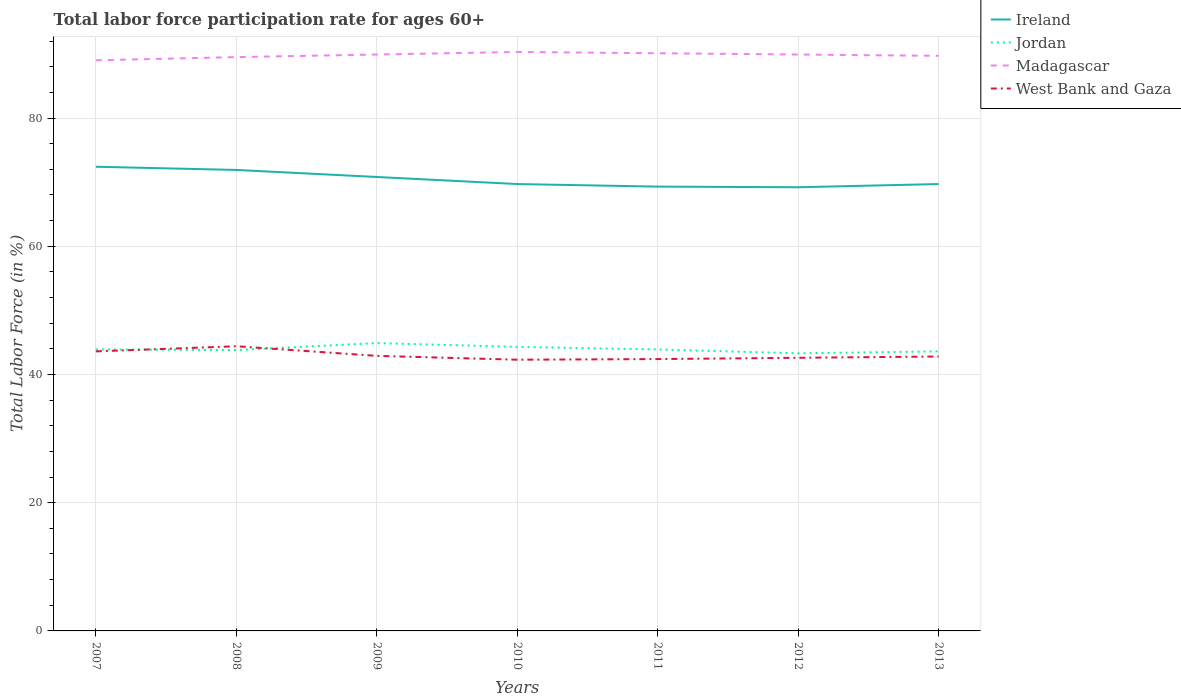How many different coloured lines are there?
Keep it short and to the point. 4. Is the number of lines equal to the number of legend labels?
Give a very brief answer. Yes. Across all years, what is the maximum labor force participation rate in Ireland?
Make the answer very short. 69.2. In which year was the labor force participation rate in Ireland maximum?
Ensure brevity in your answer.  2012. What is the total labor force participation rate in Jordan in the graph?
Offer a very short reply. 0.6. What is the difference between the highest and the second highest labor force participation rate in Ireland?
Your answer should be compact. 3.2. What is the difference between the highest and the lowest labor force participation rate in West Bank and Gaza?
Give a very brief answer. 2. Is the labor force participation rate in Jordan strictly greater than the labor force participation rate in Ireland over the years?
Keep it short and to the point. Yes. How many years are there in the graph?
Offer a very short reply. 7. What is the difference between two consecutive major ticks on the Y-axis?
Make the answer very short. 20. Does the graph contain any zero values?
Provide a short and direct response. No. Does the graph contain grids?
Keep it short and to the point. Yes. How many legend labels are there?
Your response must be concise. 4. How are the legend labels stacked?
Provide a short and direct response. Vertical. What is the title of the graph?
Offer a very short reply. Total labor force participation rate for ages 60+. What is the Total Labor Force (in %) of Ireland in 2007?
Make the answer very short. 72.4. What is the Total Labor Force (in %) of Jordan in 2007?
Your answer should be compact. 43.9. What is the Total Labor Force (in %) of Madagascar in 2007?
Offer a terse response. 89. What is the Total Labor Force (in %) of West Bank and Gaza in 2007?
Give a very brief answer. 43.6. What is the Total Labor Force (in %) of Ireland in 2008?
Provide a short and direct response. 71.9. What is the Total Labor Force (in %) of Jordan in 2008?
Provide a succinct answer. 43.8. What is the Total Labor Force (in %) of Madagascar in 2008?
Your answer should be very brief. 89.5. What is the Total Labor Force (in %) in West Bank and Gaza in 2008?
Your response must be concise. 44.4. What is the Total Labor Force (in %) in Ireland in 2009?
Your response must be concise. 70.8. What is the Total Labor Force (in %) in Jordan in 2009?
Your answer should be compact. 44.9. What is the Total Labor Force (in %) in Madagascar in 2009?
Your answer should be very brief. 89.9. What is the Total Labor Force (in %) of West Bank and Gaza in 2009?
Offer a very short reply. 42.9. What is the Total Labor Force (in %) in Ireland in 2010?
Provide a short and direct response. 69.7. What is the Total Labor Force (in %) in Jordan in 2010?
Provide a short and direct response. 44.3. What is the Total Labor Force (in %) of Madagascar in 2010?
Give a very brief answer. 90.3. What is the Total Labor Force (in %) of West Bank and Gaza in 2010?
Give a very brief answer. 42.3. What is the Total Labor Force (in %) of Ireland in 2011?
Provide a succinct answer. 69.3. What is the Total Labor Force (in %) of Jordan in 2011?
Provide a succinct answer. 43.9. What is the Total Labor Force (in %) of Madagascar in 2011?
Keep it short and to the point. 90.1. What is the Total Labor Force (in %) in West Bank and Gaza in 2011?
Ensure brevity in your answer.  42.4. What is the Total Labor Force (in %) of Ireland in 2012?
Your answer should be compact. 69.2. What is the Total Labor Force (in %) in Jordan in 2012?
Provide a short and direct response. 43.3. What is the Total Labor Force (in %) of Madagascar in 2012?
Provide a short and direct response. 89.9. What is the Total Labor Force (in %) of West Bank and Gaza in 2012?
Your answer should be very brief. 42.6. What is the Total Labor Force (in %) of Ireland in 2013?
Your response must be concise. 69.7. What is the Total Labor Force (in %) of Jordan in 2013?
Offer a terse response. 43.6. What is the Total Labor Force (in %) in Madagascar in 2013?
Give a very brief answer. 89.7. What is the Total Labor Force (in %) in West Bank and Gaza in 2013?
Keep it short and to the point. 42.8. Across all years, what is the maximum Total Labor Force (in %) in Ireland?
Provide a short and direct response. 72.4. Across all years, what is the maximum Total Labor Force (in %) of Jordan?
Your answer should be compact. 44.9. Across all years, what is the maximum Total Labor Force (in %) of Madagascar?
Your answer should be compact. 90.3. Across all years, what is the maximum Total Labor Force (in %) in West Bank and Gaza?
Provide a succinct answer. 44.4. Across all years, what is the minimum Total Labor Force (in %) in Ireland?
Provide a succinct answer. 69.2. Across all years, what is the minimum Total Labor Force (in %) of Jordan?
Your answer should be very brief. 43.3. Across all years, what is the minimum Total Labor Force (in %) of Madagascar?
Your answer should be very brief. 89. Across all years, what is the minimum Total Labor Force (in %) in West Bank and Gaza?
Your response must be concise. 42.3. What is the total Total Labor Force (in %) of Ireland in the graph?
Ensure brevity in your answer.  493. What is the total Total Labor Force (in %) of Jordan in the graph?
Offer a terse response. 307.7. What is the total Total Labor Force (in %) in Madagascar in the graph?
Offer a very short reply. 628.4. What is the total Total Labor Force (in %) of West Bank and Gaza in the graph?
Your answer should be very brief. 301. What is the difference between the Total Labor Force (in %) in Jordan in 2007 and that in 2008?
Your response must be concise. 0.1. What is the difference between the Total Labor Force (in %) in Madagascar in 2007 and that in 2008?
Your response must be concise. -0.5. What is the difference between the Total Labor Force (in %) in Ireland in 2007 and that in 2009?
Give a very brief answer. 1.6. What is the difference between the Total Labor Force (in %) in Ireland in 2007 and that in 2010?
Keep it short and to the point. 2.7. What is the difference between the Total Labor Force (in %) in Jordan in 2007 and that in 2010?
Offer a terse response. -0.4. What is the difference between the Total Labor Force (in %) in Madagascar in 2007 and that in 2011?
Keep it short and to the point. -1.1. What is the difference between the Total Labor Force (in %) in Ireland in 2007 and that in 2012?
Offer a very short reply. 3.2. What is the difference between the Total Labor Force (in %) in Jordan in 2007 and that in 2012?
Provide a short and direct response. 0.6. What is the difference between the Total Labor Force (in %) in Madagascar in 2007 and that in 2012?
Offer a very short reply. -0.9. What is the difference between the Total Labor Force (in %) in West Bank and Gaza in 2007 and that in 2012?
Your response must be concise. 1. What is the difference between the Total Labor Force (in %) of Ireland in 2007 and that in 2013?
Your answer should be very brief. 2.7. What is the difference between the Total Labor Force (in %) of Jordan in 2007 and that in 2013?
Give a very brief answer. 0.3. What is the difference between the Total Labor Force (in %) of Madagascar in 2007 and that in 2013?
Your response must be concise. -0.7. What is the difference between the Total Labor Force (in %) of Jordan in 2008 and that in 2009?
Offer a terse response. -1.1. What is the difference between the Total Labor Force (in %) in Jordan in 2008 and that in 2010?
Your answer should be compact. -0.5. What is the difference between the Total Labor Force (in %) in Madagascar in 2008 and that in 2010?
Your answer should be very brief. -0.8. What is the difference between the Total Labor Force (in %) in Ireland in 2008 and that in 2011?
Offer a very short reply. 2.6. What is the difference between the Total Labor Force (in %) in Madagascar in 2008 and that in 2011?
Your answer should be very brief. -0.6. What is the difference between the Total Labor Force (in %) of Jordan in 2008 and that in 2012?
Provide a short and direct response. 0.5. What is the difference between the Total Labor Force (in %) of Madagascar in 2008 and that in 2012?
Your answer should be very brief. -0.4. What is the difference between the Total Labor Force (in %) in Ireland in 2008 and that in 2013?
Offer a very short reply. 2.2. What is the difference between the Total Labor Force (in %) of Jordan in 2009 and that in 2010?
Provide a short and direct response. 0.6. What is the difference between the Total Labor Force (in %) of Madagascar in 2009 and that in 2010?
Offer a terse response. -0.4. What is the difference between the Total Labor Force (in %) in Ireland in 2009 and that in 2011?
Offer a terse response. 1.5. What is the difference between the Total Labor Force (in %) in Jordan in 2009 and that in 2011?
Your answer should be very brief. 1. What is the difference between the Total Labor Force (in %) of Madagascar in 2009 and that in 2012?
Keep it short and to the point. 0. What is the difference between the Total Labor Force (in %) in Ireland in 2009 and that in 2013?
Your answer should be very brief. 1.1. What is the difference between the Total Labor Force (in %) in Madagascar in 2009 and that in 2013?
Your answer should be compact. 0.2. What is the difference between the Total Labor Force (in %) of West Bank and Gaza in 2009 and that in 2013?
Your response must be concise. 0.1. What is the difference between the Total Labor Force (in %) of West Bank and Gaza in 2010 and that in 2011?
Give a very brief answer. -0.1. What is the difference between the Total Labor Force (in %) of Madagascar in 2010 and that in 2012?
Offer a terse response. 0.4. What is the difference between the Total Labor Force (in %) of Ireland in 2010 and that in 2013?
Make the answer very short. 0. What is the difference between the Total Labor Force (in %) of West Bank and Gaza in 2010 and that in 2013?
Provide a short and direct response. -0.5. What is the difference between the Total Labor Force (in %) of Madagascar in 2011 and that in 2012?
Ensure brevity in your answer.  0.2. What is the difference between the Total Labor Force (in %) of West Bank and Gaza in 2011 and that in 2012?
Provide a succinct answer. -0.2. What is the difference between the Total Labor Force (in %) in Jordan in 2011 and that in 2013?
Provide a succinct answer. 0.3. What is the difference between the Total Labor Force (in %) in Madagascar in 2011 and that in 2013?
Give a very brief answer. 0.4. What is the difference between the Total Labor Force (in %) in West Bank and Gaza in 2011 and that in 2013?
Offer a very short reply. -0.4. What is the difference between the Total Labor Force (in %) of Jordan in 2012 and that in 2013?
Your response must be concise. -0.3. What is the difference between the Total Labor Force (in %) in West Bank and Gaza in 2012 and that in 2013?
Ensure brevity in your answer.  -0.2. What is the difference between the Total Labor Force (in %) of Ireland in 2007 and the Total Labor Force (in %) of Jordan in 2008?
Your answer should be very brief. 28.6. What is the difference between the Total Labor Force (in %) of Ireland in 2007 and the Total Labor Force (in %) of Madagascar in 2008?
Give a very brief answer. -17.1. What is the difference between the Total Labor Force (in %) in Jordan in 2007 and the Total Labor Force (in %) in Madagascar in 2008?
Provide a succinct answer. -45.6. What is the difference between the Total Labor Force (in %) of Jordan in 2007 and the Total Labor Force (in %) of West Bank and Gaza in 2008?
Your answer should be compact. -0.5. What is the difference between the Total Labor Force (in %) in Madagascar in 2007 and the Total Labor Force (in %) in West Bank and Gaza in 2008?
Your response must be concise. 44.6. What is the difference between the Total Labor Force (in %) in Ireland in 2007 and the Total Labor Force (in %) in Jordan in 2009?
Offer a very short reply. 27.5. What is the difference between the Total Labor Force (in %) in Ireland in 2007 and the Total Labor Force (in %) in Madagascar in 2009?
Provide a succinct answer. -17.5. What is the difference between the Total Labor Force (in %) of Ireland in 2007 and the Total Labor Force (in %) of West Bank and Gaza in 2009?
Offer a terse response. 29.5. What is the difference between the Total Labor Force (in %) of Jordan in 2007 and the Total Labor Force (in %) of Madagascar in 2009?
Your response must be concise. -46. What is the difference between the Total Labor Force (in %) of Madagascar in 2007 and the Total Labor Force (in %) of West Bank and Gaza in 2009?
Offer a very short reply. 46.1. What is the difference between the Total Labor Force (in %) of Ireland in 2007 and the Total Labor Force (in %) of Jordan in 2010?
Keep it short and to the point. 28.1. What is the difference between the Total Labor Force (in %) in Ireland in 2007 and the Total Labor Force (in %) in Madagascar in 2010?
Offer a very short reply. -17.9. What is the difference between the Total Labor Force (in %) in Ireland in 2007 and the Total Labor Force (in %) in West Bank and Gaza in 2010?
Offer a very short reply. 30.1. What is the difference between the Total Labor Force (in %) of Jordan in 2007 and the Total Labor Force (in %) of Madagascar in 2010?
Offer a terse response. -46.4. What is the difference between the Total Labor Force (in %) of Jordan in 2007 and the Total Labor Force (in %) of West Bank and Gaza in 2010?
Offer a very short reply. 1.6. What is the difference between the Total Labor Force (in %) in Madagascar in 2007 and the Total Labor Force (in %) in West Bank and Gaza in 2010?
Your answer should be very brief. 46.7. What is the difference between the Total Labor Force (in %) of Ireland in 2007 and the Total Labor Force (in %) of Jordan in 2011?
Your answer should be compact. 28.5. What is the difference between the Total Labor Force (in %) in Ireland in 2007 and the Total Labor Force (in %) in Madagascar in 2011?
Your response must be concise. -17.7. What is the difference between the Total Labor Force (in %) in Jordan in 2007 and the Total Labor Force (in %) in Madagascar in 2011?
Your answer should be very brief. -46.2. What is the difference between the Total Labor Force (in %) of Jordan in 2007 and the Total Labor Force (in %) of West Bank and Gaza in 2011?
Keep it short and to the point. 1.5. What is the difference between the Total Labor Force (in %) of Madagascar in 2007 and the Total Labor Force (in %) of West Bank and Gaza in 2011?
Ensure brevity in your answer.  46.6. What is the difference between the Total Labor Force (in %) in Ireland in 2007 and the Total Labor Force (in %) in Jordan in 2012?
Give a very brief answer. 29.1. What is the difference between the Total Labor Force (in %) in Ireland in 2007 and the Total Labor Force (in %) in Madagascar in 2012?
Offer a very short reply. -17.5. What is the difference between the Total Labor Force (in %) in Ireland in 2007 and the Total Labor Force (in %) in West Bank and Gaza in 2012?
Offer a very short reply. 29.8. What is the difference between the Total Labor Force (in %) in Jordan in 2007 and the Total Labor Force (in %) in Madagascar in 2012?
Provide a short and direct response. -46. What is the difference between the Total Labor Force (in %) in Madagascar in 2007 and the Total Labor Force (in %) in West Bank and Gaza in 2012?
Your answer should be compact. 46.4. What is the difference between the Total Labor Force (in %) in Ireland in 2007 and the Total Labor Force (in %) in Jordan in 2013?
Provide a short and direct response. 28.8. What is the difference between the Total Labor Force (in %) of Ireland in 2007 and the Total Labor Force (in %) of Madagascar in 2013?
Your answer should be very brief. -17.3. What is the difference between the Total Labor Force (in %) in Ireland in 2007 and the Total Labor Force (in %) in West Bank and Gaza in 2013?
Provide a succinct answer. 29.6. What is the difference between the Total Labor Force (in %) in Jordan in 2007 and the Total Labor Force (in %) in Madagascar in 2013?
Provide a short and direct response. -45.8. What is the difference between the Total Labor Force (in %) of Jordan in 2007 and the Total Labor Force (in %) of West Bank and Gaza in 2013?
Provide a short and direct response. 1.1. What is the difference between the Total Labor Force (in %) in Madagascar in 2007 and the Total Labor Force (in %) in West Bank and Gaza in 2013?
Provide a succinct answer. 46.2. What is the difference between the Total Labor Force (in %) of Ireland in 2008 and the Total Labor Force (in %) of Jordan in 2009?
Provide a short and direct response. 27. What is the difference between the Total Labor Force (in %) of Ireland in 2008 and the Total Labor Force (in %) of Madagascar in 2009?
Ensure brevity in your answer.  -18. What is the difference between the Total Labor Force (in %) in Jordan in 2008 and the Total Labor Force (in %) in Madagascar in 2009?
Offer a terse response. -46.1. What is the difference between the Total Labor Force (in %) in Jordan in 2008 and the Total Labor Force (in %) in West Bank and Gaza in 2009?
Offer a very short reply. 0.9. What is the difference between the Total Labor Force (in %) of Madagascar in 2008 and the Total Labor Force (in %) of West Bank and Gaza in 2009?
Offer a terse response. 46.6. What is the difference between the Total Labor Force (in %) in Ireland in 2008 and the Total Labor Force (in %) in Jordan in 2010?
Ensure brevity in your answer.  27.6. What is the difference between the Total Labor Force (in %) of Ireland in 2008 and the Total Labor Force (in %) of Madagascar in 2010?
Your answer should be very brief. -18.4. What is the difference between the Total Labor Force (in %) in Ireland in 2008 and the Total Labor Force (in %) in West Bank and Gaza in 2010?
Give a very brief answer. 29.6. What is the difference between the Total Labor Force (in %) in Jordan in 2008 and the Total Labor Force (in %) in Madagascar in 2010?
Provide a succinct answer. -46.5. What is the difference between the Total Labor Force (in %) in Jordan in 2008 and the Total Labor Force (in %) in West Bank and Gaza in 2010?
Keep it short and to the point. 1.5. What is the difference between the Total Labor Force (in %) in Madagascar in 2008 and the Total Labor Force (in %) in West Bank and Gaza in 2010?
Provide a short and direct response. 47.2. What is the difference between the Total Labor Force (in %) of Ireland in 2008 and the Total Labor Force (in %) of Jordan in 2011?
Offer a terse response. 28. What is the difference between the Total Labor Force (in %) in Ireland in 2008 and the Total Labor Force (in %) in Madagascar in 2011?
Make the answer very short. -18.2. What is the difference between the Total Labor Force (in %) of Ireland in 2008 and the Total Labor Force (in %) of West Bank and Gaza in 2011?
Offer a terse response. 29.5. What is the difference between the Total Labor Force (in %) in Jordan in 2008 and the Total Labor Force (in %) in Madagascar in 2011?
Keep it short and to the point. -46.3. What is the difference between the Total Labor Force (in %) in Madagascar in 2008 and the Total Labor Force (in %) in West Bank and Gaza in 2011?
Keep it short and to the point. 47.1. What is the difference between the Total Labor Force (in %) of Ireland in 2008 and the Total Labor Force (in %) of Jordan in 2012?
Ensure brevity in your answer.  28.6. What is the difference between the Total Labor Force (in %) of Ireland in 2008 and the Total Labor Force (in %) of Madagascar in 2012?
Offer a very short reply. -18. What is the difference between the Total Labor Force (in %) in Ireland in 2008 and the Total Labor Force (in %) in West Bank and Gaza in 2012?
Your response must be concise. 29.3. What is the difference between the Total Labor Force (in %) of Jordan in 2008 and the Total Labor Force (in %) of Madagascar in 2012?
Your answer should be very brief. -46.1. What is the difference between the Total Labor Force (in %) in Jordan in 2008 and the Total Labor Force (in %) in West Bank and Gaza in 2012?
Ensure brevity in your answer.  1.2. What is the difference between the Total Labor Force (in %) in Madagascar in 2008 and the Total Labor Force (in %) in West Bank and Gaza in 2012?
Your response must be concise. 46.9. What is the difference between the Total Labor Force (in %) in Ireland in 2008 and the Total Labor Force (in %) in Jordan in 2013?
Provide a short and direct response. 28.3. What is the difference between the Total Labor Force (in %) in Ireland in 2008 and the Total Labor Force (in %) in Madagascar in 2013?
Provide a succinct answer. -17.8. What is the difference between the Total Labor Force (in %) of Ireland in 2008 and the Total Labor Force (in %) of West Bank and Gaza in 2013?
Give a very brief answer. 29.1. What is the difference between the Total Labor Force (in %) in Jordan in 2008 and the Total Labor Force (in %) in Madagascar in 2013?
Provide a short and direct response. -45.9. What is the difference between the Total Labor Force (in %) in Jordan in 2008 and the Total Labor Force (in %) in West Bank and Gaza in 2013?
Your answer should be very brief. 1. What is the difference between the Total Labor Force (in %) in Madagascar in 2008 and the Total Labor Force (in %) in West Bank and Gaza in 2013?
Ensure brevity in your answer.  46.7. What is the difference between the Total Labor Force (in %) of Ireland in 2009 and the Total Labor Force (in %) of Madagascar in 2010?
Offer a very short reply. -19.5. What is the difference between the Total Labor Force (in %) of Jordan in 2009 and the Total Labor Force (in %) of Madagascar in 2010?
Your response must be concise. -45.4. What is the difference between the Total Labor Force (in %) in Jordan in 2009 and the Total Labor Force (in %) in West Bank and Gaza in 2010?
Your answer should be compact. 2.6. What is the difference between the Total Labor Force (in %) of Madagascar in 2009 and the Total Labor Force (in %) of West Bank and Gaza in 2010?
Your answer should be very brief. 47.6. What is the difference between the Total Labor Force (in %) of Ireland in 2009 and the Total Labor Force (in %) of Jordan in 2011?
Your answer should be compact. 26.9. What is the difference between the Total Labor Force (in %) of Ireland in 2009 and the Total Labor Force (in %) of Madagascar in 2011?
Your answer should be very brief. -19.3. What is the difference between the Total Labor Force (in %) of Ireland in 2009 and the Total Labor Force (in %) of West Bank and Gaza in 2011?
Your response must be concise. 28.4. What is the difference between the Total Labor Force (in %) in Jordan in 2009 and the Total Labor Force (in %) in Madagascar in 2011?
Offer a very short reply. -45.2. What is the difference between the Total Labor Force (in %) of Jordan in 2009 and the Total Labor Force (in %) of West Bank and Gaza in 2011?
Provide a short and direct response. 2.5. What is the difference between the Total Labor Force (in %) in Madagascar in 2009 and the Total Labor Force (in %) in West Bank and Gaza in 2011?
Give a very brief answer. 47.5. What is the difference between the Total Labor Force (in %) of Ireland in 2009 and the Total Labor Force (in %) of Jordan in 2012?
Your answer should be very brief. 27.5. What is the difference between the Total Labor Force (in %) in Ireland in 2009 and the Total Labor Force (in %) in Madagascar in 2012?
Offer a terse response. -19.1. What is the difference between the Total Labor Force (in %) of Ireland in 2009 and the Total Labor Force (in %) of West Bank and Gaza in 2012?
Your response must be concise. 28.2. What is the difference between the Total Labor Force (in %) of Jordan in 2009 and the Total Labor Force (in %) of Madagascar in 2012?
Make the answer very short. -45. What is the difference between the Total Labor Force (in %) of Madagascar in 2009 and the Total Labor Force (in %) of West Bank and Gaza in 2012?
Keep it short and to the point. 47.3. What is the difference between the Total Labor Force (in %) of Ireland in 2009 and the Total Labor Force (in %) of Jordan in 2013?
Provide a succinct answer. 27.2. What is the difference between the Total Labor Force (in %) of Ireland in 2009 and the Total Labor Force (in %) of Madagascar in 2013?
Your answer should be very brief. -18.9. What is the difference between the Total Labor Force (in %) of Jordan in 2009 and the Total Labor Force (in %) of Madagascar in 2013?
Provide a short and direct response. -44.8. What is the difference between the Total Labor Force (in %) in Jordan in 2009 and the Total Labor Force (in %) in West Bank and Gaza in 2013?
Make the answer very short. 2.1. What is the difference between the Total Labor Force (in %) in Madagascar in 2009 and the Total Labor Force (in %) in West Bank and Gaza in 2013?
Ensure brevity in your answer.  47.1. What is the difference between the Total Labor Force (in %) in Ireland in 2010 and the Total Labor Force (in %) in Jordan in 2011?
Give a very brief answer. 25.8. What is the difference between the Total Labor Force (in %) in Ireland in 2010 and the Total Labor Force (in %) in Madagascar in 2011?
Your answer should be very brief. -20.4. What is the difference between the Total Labor Force (in %) in Ireland in 2010 and the Total Labor Force (in %) in West Bank and Gaza in 2011?
Give a very brief answer. 27.3. What is the difference between the Total Labor Force (in %) in Jordan in 2010 and the Total Labor Force (in %) in Madagascar in 2011?
Provide a short and direct response. -45.8. What is the difference between the Total Labor Force (in %) of Jordan in 2010 and the Total Labor Force (in %) of West Bank and Gaza in 2011?
Your answer should be compact. 1.9. What is the difference between the Total Labor Force (in %) in Madagascar in 2010 and the Total Labor Force (in %) in West Bank and Gaza in 2011?
Provide a short and direct response. 47.9. What is the difference between the Total Labor Force (in %) in Ireland in 2010 and the Total Labor Force (in %) in Jordan in 2012?
Offer a terse response. 26.4. What is the difference between the Total Labor Force (in %) of Ireland in 2010 and the Total Labor Force (in %) of Madagascar in 2012?
Ensure brevity in your answer.  -20.2. What is the difference between the Total Labor Force (in %) of Ireland in 2010 and the Total Labor Force (in %) of West Bank and Gaza in 2012?
Make the answer very short. 27.1. What is the difference between the Total Labor Force (in %) in Jordan in 2010 and the Total Labor Force (in %) in Madagascar in 2012?
Ensure brevity in your answer.  -45.6. What is the difference between the Total Labor Force (in %) in Jordan in 2010 and the Total Labor Force (in %) in West Bank and Gaza in 2012?
Provide a short and direct response. 1.7. What is the difference between the Total Labor Force (in %) of Madagascar in 2010 and the Total Labor Force (in %) of West Bank and Gaza in 2012?
Your answer should be compact. 47.7. What is the difference between the Total Labor Force (in %) in Ireland in 2010 and the Total Labor Force (in %) in Jordan in 2013?
Give a very brief answer. 26.1. What is the difference between the Total Labor Force (in %) of Ireland in 2010 and the Total Labor Force (in %) of Madagascar in 2013?
Provide a succinct answer. -20. What is the difference between the Total Labor Force (in %) in Ireland in 2010 and the Total Labor Force (in %) in West Bank and Gaza in 2013?
Your response must be concise. 26.9. What is the difference between the Total Labor Force (in %) in Jordan in 2010 and the Total Labor Force (in %) in Madagascar in 2013?
Your answer should be compact. -45.4. What is the difference between the Total Labor Force (in %) in Jordan in 2010 and the Total Labor Force (in %) in West Bank and Gaza in 2013?
Your answer should be compact. 1.5. What is the difference between the Total Labor Force (in %) of Madagascar in 2010 and the Total Labor Force (in %) of West Bank and Gaza in 2013?
Ensure brevity in your answer.  47.5. What is the difference between the Total Labor Force (in %) of Ireland in 2011 and the Total Labor Force (in %) of Madagascar in 2012?
Your answer should be very brief. -20.6. What is the difference between the Total Labor Force (in %) in Ireland in 2011 and the Total Labor Force (in %) in West Bank and Gaza in 2012?
Your answer should be very brief. 26.7. What is the difference between the Total Labor Force (in %) of Jordan in 2011 and the Total Labor Force (in %) of Madagascar in 2012?
Make the answer very short. -46. What is the difference between the Total Labor Force (in %) of Jordan in 2011 and the Total Labor Force (in %) of West Bank and Gaza in 2012?
Give a very brief answer. 1.3. What is the difference between the Total Labor Force (in %) of Madagascar in 2011 and the Total Labor Force (in %) of West Bank and Gaza in 2012?
Keep it short and to the point. 47.5. What is the difference between the Total Labor Force (in %) of Ireland in 2011 and the Total Labor Force (in %) of Jordan in 2013?
Offer a terse response. 25.7. What is the difference between the Total Labor Force (in %) in Ireland in 2011 and the Total Labor Force (in %) in Madagascar in 2013?
Make the answer very short. -20.4. What is the difference between the Total Labor Force (in %) in Ireland in 2011 and the Total Labor Force (in %) in West Bank and Gaza in 2013?
Your answer should be compact. 26.5. What is the difference between the Total Labor Force (in %) in Jordan in 2011 and the Total Labor Force (in %) in Madagascar in 2013?
Offer a terse response. -45.8. What is the difference between the Total Labor Force (in %) of Jordan in 2011 and the Total Labor Force (in %) of West Bank and Gaza in 2013?
Make the answer very short. 1.1. What is the difference between the Total Labor Force (in %) in Madagascar in 2011 and the Total Labor Force (in %) in West Bank and Gaza in 2013?
Give a very brief answer. 47.3. What is the difference between the Total Labor Force (in %) of Ireland in 2012 and the Total Labor Force (in %) of Jordan in 2013?
Offer a very short reply. 25.6. What is the difference between the Total Labor Force (in %) of Ireland in 2012 and the Total Labor Force (in %) of Madagascar in 2013?
Your answer should be very brief. -20.5. What is the difference between the Total Labor Force (in %) of Ireland in 2012 and the Total Labor Force (in %) of West Bank and Gaza in 2013?
Your answer should be compact. 26.4. What is the difference between the Total Labor Force (in %) of Jordan in 2012 and the Total Labor Force (in %) of Madagascar in 2013?
Make the answer very short. -46.4. What is the difference between the Total Labor Force (in %) in Jordan in 2012 and the Total Labor Force (in %) in West Bank and Gaza in 2013?
Give a very brief answer. 0.5. What is the difference between the Total Labor Force (in %) in Madagascar in 2012 and the Total Labor Force (in %) in West Bank and Gaza in 2013?
Make the answer very short. 47.1. What is the average Total Labor Force (in %) in Ireland per year?
Make the answer very short. 70.43. What is the average Total Labor Force (in %) in Jordan per year?
Your response must be concise. 43.96. What is the average Total Labor Force (in %) of Madagascar per year?
Give a very brief answer. 89.77. In the year 2007, what is the difference between the Total Labor Force (in %) of Ireland and Total Labor Force (in %) of Jordan?
Keep it short and to the point. 28.5. In the year 2007, what is the difference between the Total Labor Force (in %) in Ireland and Total Labor Force (in %) in Madagascar?
Your response must be concise. -16.6. In the year 2007, what is the difference between the Total Labor Force (in %) in Ireland and Total Labor Force (in %) in West Bank and Gaza?
Offer a terse response. 28.8. In the year 2007, what is the difference between the Total Labor Force (in %) in Jordan and Total Labor Force (in %) in Madagascar?
Provide a short and direct response. -45.1. In the year 2007, what is the difference between the Total Labor Force (in %) of Jordan and Total Labor Force (in %) of West Bank and Gaza?
Offer a very short reply. 0.3. In the year 2007, what is the difference between the Total Labor Force (in %) in Madagascar and Total Labor Force (in %) in West Bank and Gaza?
Provide a short and direct response. 45.4. In the year 2008, what is the difference between the Total Labor Force (in %) of Ireland and Total Labor Force (in %) of Jordan?
Make the answer very short. 28.1. In the year 2008, what is the difference between the Total Labor Force (in %) in Ireland and Total Labor Force (in %) in Madagascar?
Offer a terse response. -17.6. In the year 2008, what is the difference between the Total Labor Force (in %) of Jordan and Total Labor Force (in %) of Madagascar?
Keep it short and to the point. -45.7. In the year 2008, what is the difference between the Total Labor Force (in %) of Jordan and Total Labor Force (in %) of West Bank and Gaza?
Make the answer very short. -0.6. In the year 2008, what is the difference between the Total Labor Force (in %) in Madagascar and Total Labor Force (in %) in West Bank and Gaza?
Your response must be concise. 45.1. In the year 2009, what is the difference between the Total Labor Force (in %) in Ireland and Total Labor Force (in %) in Jordan?
Offer a terse response. 25.9. In the year 2009, what is the difference between the Total Labor Force (in %) in Ireland and Total Labor Force (in %) in Madagascar?
Give a very brief answer. -19.1. In the year 2009, what is the difference between the Total Labor Force (in %) in Ireland and Total Labor Force (in %) in West Bank and Gaza?
Offer a very short reply. 27.9. In the year 2009, what is the difference between the Total Labor Force (in %) of Jordan and Total Labor Force (in %) of Madagascar?
Offer a very short reply. -45. In the year 2009, what is the difference between the Total Labor Force (in %) in Jordan and Total Labor Force (in %) in West Bank and Gaza?
Your answer should be very brief. 2. In the year 2009, what is the difference between the Total Labor Force (in %) in Madagascar and Total Labor Force (in %) in West Bank and Gaza?
Provide a short and direct response. 47. In the year 2010, what is the difference between the Total Labor Force (in %) in Ireland and Total Labor Force (in %) in Jordan?
Offer a very short reply. 25.4. In the year 2010, what is the difference between the Total Labor Force (in %) in Ireland and Total Labor Force (in %) in Madagascar?
Give a very brief answer. -20.6. In the year 2010, what is the difference between the Total Labor Force (in %) of Ireland and Total Labor Force (in %) of West Bank and Gaza?
Offer a very short reply. 27.4. In the year 2010, what is the difference between the Total Labor Force (in %) of Jordan and Total Labor Force (in %) of Madagascar?
Keep it short and to the point. -46. In the year 2010, what is the difference between the Total Labor Force (in %) of Madagascar and Total Labor Force (in %) of West Bank and Gaza?
Your answer should be very brief. 48. In the year 2011, what is the difference between the Total Labor Force (in %) in Ireland and Total Labor Force (in %) in Jordan?
Offer a terse response. 25.4. In the year 2011, what is the difference between the Total Labor Force (in %) in Ireland and Total Labor Force (in %) in Madagascar?
Offer a terse response. -20.8. In the year 2011, what is the difference between the Total Labor Force (in %) in Ireland and Total Labor Force (in %) in West Bank and Gaza?
Your answer should be compact. 26.9. In the year 2011, what is the difference between the Total Labor Force (in %) of Jordan and Total Labor Force (in %) of Madagascar?
Ensure brevity in your answer.  -46.2. In the year 2011, what is the difference between the Total Labor Force (in %) in Madagascar and Total Labor Force (in %) in West Bank and Gaza?
Keep it short and to the point. 47.7. In the year 2012, what is the difference between the Total Labor Force (in %) in Ireland and Total Labor Force (in %) in Jordan?
Provide a short and direct response. 25.9. In the year 2012, what is the difference between the Total Labor Force (in %) in Ireland and Total Labor Force (in %) in Madagascar?
Your answer should be very brief. -20.7. In the year 2012, what is the difference between the Total Labor Force (in %) in Ireland and Total Labor Force (in %) in West Bank and Gaza?
Your answer should be very brief. 26.6. In the year 2012, what is the difference between the Total Labor Force (in %) of Jordan and Total Labor Force (in %) of Madagascar?
Ensure brevity in your answer.  -46.6. In the year 2012, what is the difference between the Total Labor Force (in %) of Madagascar and Total Labor Force (in %) of West Bank and Gaza?
Give a very brief answer. 47.3. In the year 2013, what is the difference between the Total Labor Force (in %) of Ireland and Total Labor Force (in %) of Jordan?
Provide a short and direct response. 26.1. In the year 2013, what is the difference between the Total Labor Force (in %) of Ireland and Total Labor Force (in %) of Madagascar?
Make the answer very short. -20. In the year 2013, what is the difference between the Total Labor Force (in %) of Ireland and Total Labor Force (in %) of West Bank and Gaza?
Your answer should be compact. 26.9. In the year 2013, what is the difference between the Total Labor Force (in %) in Jordan and Total Labor Force (in %) in Madagascar?
Offer a very short reply. -46.1. In the year 2013, what is the difference between the Total Labor Force (in %) of Jordan and Total Labor Force (in %) of West Bank and Gaza?
Your answer should be very brief. 0.8. In the year 2013, what is the difference between the Total Labor Force (in %) of Madagascar and Total Labor Force (in %) of West Bank and Gaza?
Offer a very short reply. 46.9. What is the ratio of the Total Labor Force (in %) in Ireland in 2007 to that in 2008?
Keep it short and to the point. 1.01. What is the ratio of the Total Labor Force (in %) of West Bank and Gaza in 2007 to that in 2008?
Give a very brief answer. 0.98. What is the ratio of the Total Labor Force (in %) in Ireland in 2007 to that in 2009?
Provide a succinct answer. 1.02. What is the ratio of the Total Labor Force (in %) in Jordan in 2007 to that in 2009?
Offer a very short reply. 0.98. What is the ratio of the Total Labor Force (in %) in Madagascar in 2007 to that in 2009?
Your answer should be very brief. 0.99. What is the ratio of the Total Labor Force (in %) in West Bank and Gaza in 2007 to that in 2009?
Provide a succinct answer. 1.02. What is the ratio of the Total Labor Force (in %) of Ireland in 2007 to that in 2010?
Provide a succinct answer. 1.04. What is the ratio of the Total Labor Force (in %) of Jordan in 2007 to that in 2010?
Provide a succinct answer. 0.99. What is the ratio of the Total Labor Force (in %) of Madagascar in 2007 to that in 2010?
Provide a succinct answer. 0.99. What is the ratio of the Total Labor Force (in %) in West Bank and Gaza in 2007 to that in 2010?
Offer a very short reply. 1.03. What is the ratio of the Total Labor Force (in %) in Ireland in 2007 to that in 2011?
Keep it short and to the point. 1.04. What is the ratio of the Total Labor Force (in %) in Jordan in 2007 to that in 2011?
Your response must be concise. 1. What is the ratio of the Total Labor Force (in %) of Madagascar in 2007 to that in 2011?
Your response must be concise. 0.99. What is the ratio of the Total Labor Force (in %) of West Bank and Gaza in 2007 to that in 2011?
Provide a short and direct response. 1.03. What is the ratio of the Total Labor Force (in %) in Ireland in 2007 to that in 2012?
Give a very brief answer. 1.05. What is the ratio of the Total Labor Force (in %) of Jordan in 2007 to that in 2012?
Your response must be concise. 1.01. What is the ratio of the Total Labor Force (in %) of West Bank and Gaza in 2007 to that in 2012?
Offer a very short reply. 1.02. What is the ratio of the Total Labor Force (in %) in Ireland in 2007 to that in 2013?
Keep it short and to the point. 1.04. What is the ratio of the Total Labor Force (in %) in Jordan in 2007 to that in 2013?
Offer a very short reply. 1.01. What is the ratio of the Total Labor Force (in %) in Madagascar in 2007 to that in 2013?
Provide a succinct answer. 0.99. What is the ratio of the Total Labor Force (in %) of West Bank and Gaza in 2007 to that in 2013?
Offer a very short reply. 1.02. What is the ratio of the Total Labor Force (in %) in Ireland in 2008 to that in 2009?
Offer a terse response. 1.02. What is the ratio of the Total Labor Force (in %) of Jordan in 2008 to that in 2009?
Offer a terse response. 0.98. What is the ratio of the Total Labor Force (in %) of West Bank and Gaza in 2008 to that in 2009?
Keep it short and to the point. 1.03. What is the ratio of the Total Labor Force (in %) of Ireland in 2008 to that in 2010?
Give a very brief answer. 1.03. What is the ratio of the Total Labor Force (in %) of Jordan in 2008 to that in 2010?
Your response must be concise. 0.99. What is the ratio of the Total Labor Force (in %) of Madagascar in 2008 to that in 2010?
Your response must be concise. 0.99. What is the ratio of the Total Labor Force (in %) of West Bank and Gaza in 2008 to that in 2010?
Your response must be concise. 1.05. What is the ratio of the Total Labor Force (in %) of Ireland in 2008 to that in 2011?
Offer a very short reply. 1.04. What is the ratio of the Total Labor Force (in %) in Jordan in 2008 to that in 2011?
Your answer should be compact. 1. What is the ratio of the Total Labor Force (in %) in Madagascar in 2008 to that in 2011?
Ensure brevity in your answer.  0.99. What is the ratio of the Total Labor Force (in %) in West Bank and Gaza in 2008 to that in 2011?
Keep it short and to the point. 1.05. What is the ratio of the Total Labor Force (in %) of Ireland in 2008 to that in 2012?
Your answer should be very brief. 1.04. What is the ratio of the Total Labor Force (in %) of Jordan in 2008 to that in 2012?
Your answer should be very brief. 1.01. What is the ratio of the Total Labor Force (in %) of West Bank and Gaza in 2008 to that in 2012?
Give a very brief answer. 1.04. What is the ratio of the Total Labor Force (in %) of Ireland in 2008 to that in 2013?
Give a very brief answer. 1.03. What is the ratio of the Total Labor Force (in %) in Jordan in 2008 to that in 2013?
Make the answer very short. 1. What is the ratio of the Total Labor Force (in %) of West Bank and Gaza in 2008 to that in 2013?
Ensure brevity in your answer.  1.04. What is the ratio of the Total Labor Force (in %) of Ireland in 2009 to that in 2010?
Your answer should be compact. 1.02. What is the ratio of the Total Labor Force (in %) of Jordan in 2009 to that in 2010?
Keep it short and to the point. 1.01. What is the ratio of the Total Labor Force (in %) in Madagascar in 2009 to that in 2010?
Provide a short and direct response. 1. What is the ratio of the Total Labor Force (in %) of West Bank and Gaza in 2009 to that in 2010?
Give a very brief answer. 1.01. What is the ratio of the Total Labor Force (in %) in Ireland in 2009 to that in 2011?
Make the answer very short. 1.02. What is the ratio of the Total Labor Force (in %) in Jordan in 2009 to that in 2011?
Provide a short and direct response. 1.02. What is the ratio of the Total Labor Force (in %) in West Bank and Gaza in 2009 to that in 2011?
Provide a short and direct response. 1.01. What is the ratio of the Total Labor Force (in %) of Ireland in 2009 to that in 2012?
Offer a very short reply. 1.02. What is the ratio of the Total Labor Force (in %) of Jordan in 2009 to that in 2012?
Your answer should be very brief. 1.04. What is the ratio of the Total Labor Force (in %) of Madagascar in 2009 to that in 2012?
Your answer should be compact. 1. What is the ratio of the Total Labor Force (in %) of West Bank and Gaza in 2009 to that in 2012?
Provide a succinct answer. 1.01. What is the ratio of the Total Labor Force (in %) in Ireland in 2009 to that in 2013?
Give a very brief answer. 1.02. What is the ratio of the Total Labor Force (in %) in Jordan in 2009 to that in 2013?
Ensure brevity in your answer.  1.03. What is the ratio of the Total Labor Force (in %) of Ireland in 2010 to that in 2011?
Ensure brevity in your answer.  1.01. What is the ratio of the Total Labor Force (in %) of Jordan in 2010 to that in 2011?
Your response must be concise. 1.01. What is the ratio of the Total Labor Force (in %) in Jordan in 2010 to that in 2012?
Your answer should be very brief. 1.02. What is the ratio of the Total Labor Force (in %) in Ireland in 2010 to that in 2013?
Provide a succinct answer. 1. What is the ratio of the Total Labor Force (in %) in Jordan in 2010 to that in 2013?
Ensure brevity in your answer.  1.02. What is the ratio of the Total Labor Force (in %) in West Bank and Gaza in 2010 to that in 2013?
Provide a short and direct response. 0.99. What is the ratio of the Total Labor Force (in %) in Ireland in 2011 to that in 2012?
Your answer should be very brief. 1. What is the ratio of the Total Labor Force (in %) in Jordan in 2011 to that in 2012?
Your response must be concise. 1.01. What is the ratio of the Total Labor Force (in %) of West Bank and Gaza in 2011 to that in 2012?
Provide a succinct answer. 1. What is the ratio of the Total Labor Force (in %) of Jordan in 2011 to that in 2013?
Offer a terse response. 1.01. What is the ratio of the Total Labor Force (in %) of Madagascar in 2011 to that in 2013?
Provide a short and direct response. 1. What is the ratio of the Total Labor Force (in %) of Jordan in 2012 to that in 2013?
Offer a very short reply. 0.99. What is the ratio of the Total Labor Force (in %) in Madagascar in 2012 to that in 2013?
Make the answer very short. 1. What is the difference between the highest and the second highest Total Labor Force (in %) in Madagascar?
Make the answer very short. 0.2. What is the difference between the highest and the lowest Total Labor Force (in %) in Ireland?
Your response must be concise. 3.2. What is the difference between the highest and the lowest Total Labor Force (in %) in Madagascar?
Give a very brief answer. 1.3. What is the difference between the highest and the lowest Total Labor Force (in %) of West Bank and Gaza?
Offer a terse response. 2.1. 